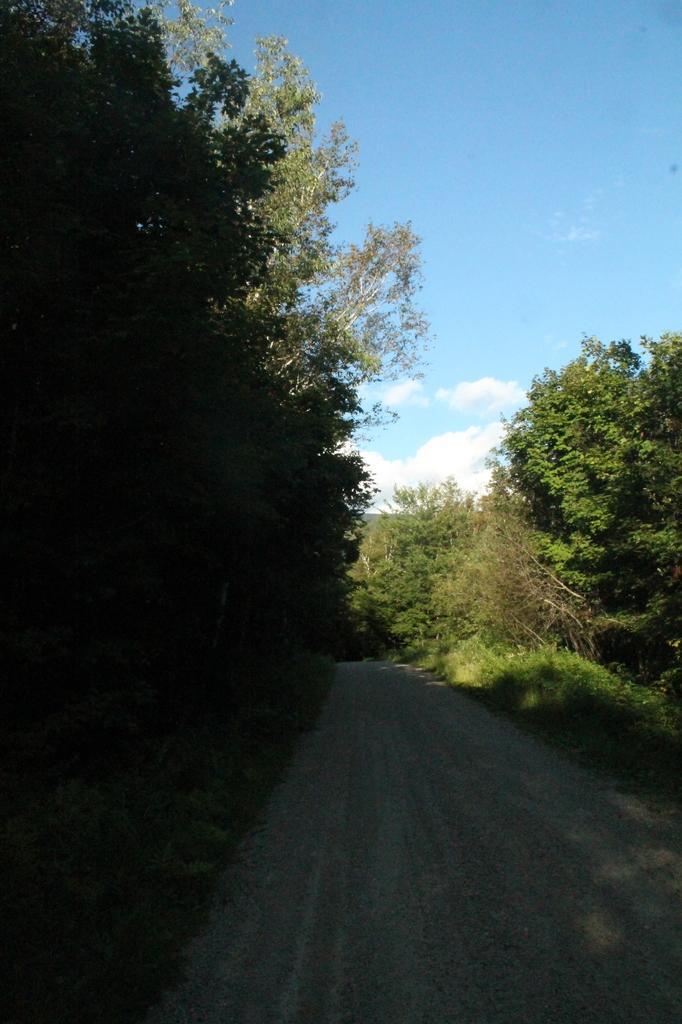Describe this image in one or two sentences. In this image I can see a road. On the left and right side, I can see the trees. In the background, I can see the clouds in the sky. 